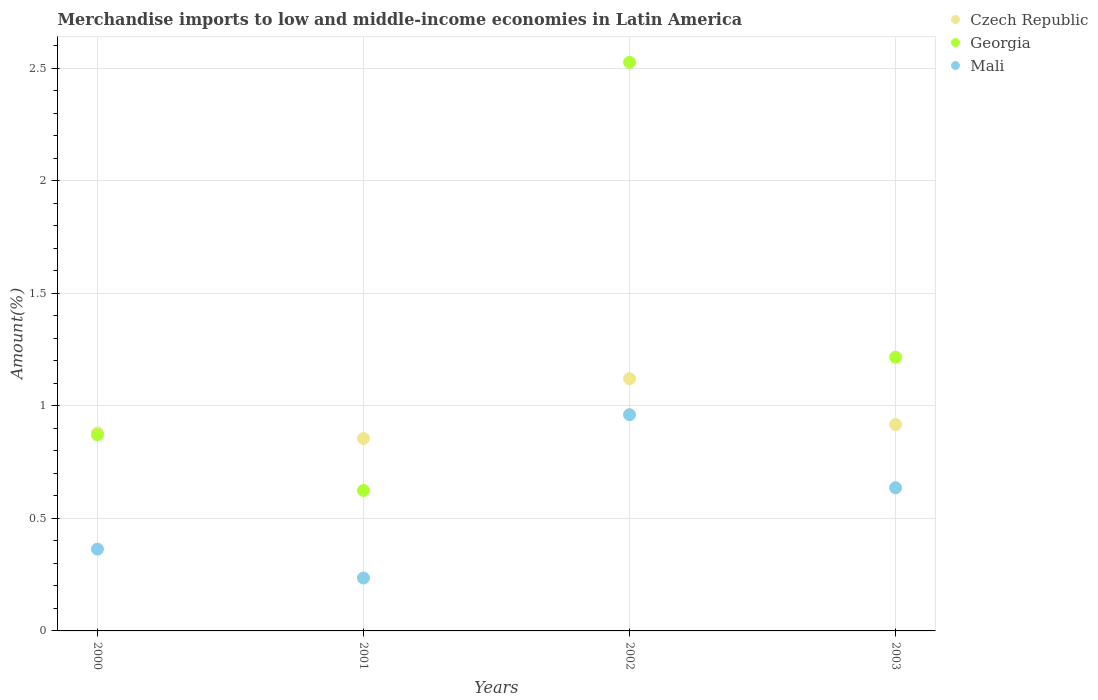How many different coloured dotlines are there?
Ensure brevity in your answer.  3. Is the number of dotlines equal to the number of legend labels?
Offer a very short reply. Yes. What is the percentage of amount earned from merchandise imports in Czech Republic in 2000?
Keep it short and to the point. 0.88. Across all years, what is the maximum percentage of amount earned from merchandise imports in Czech Republic?
Your answer should be very brief. 1.12. Across all years, what is the minimum percentage of amount earned from merchandise imports in Mali?
Your answer should be very brief. 0.24. What is the total percentage of amount earned from merchandise imports in Czech Republic in the graph?
Make the answer very short. 3.77. What is the difference between the percentage of amount earned from merchandise imports in Mali in 2000 and that in 2003?
Your answer should be very brief. -0.27. What is the difference between the percentage of amount earned from merchandise imports in Mali in 2002 and the percentage of amount earned from merchandise imports in Georgia in 2000?
Provide a succinct answer. 0.09. What is the average percentage of amount earned from merchandise imports in Mali per year?
Your response must be concise. 0.55. In the year 2000, what is the difference between the percentage of amount earned from merchandise imports in Georgia and percentage of amount earned from merchandise imports in Czech Republic?
Make the answer very short. -0.01. In how many years, is the percentage of amount earned from merchandise imports in Mali greater than 1.6 %?
Make the answer very short. 0. What is the ratio of the percentage of amount earned from merchandise imports in Georgia in 2001 to that in 2003?
Your answer should be compact. 0.51. Is the difference between the percentage of amount earned from merchandise imports in Georgia in 2000 and 2001 greater than the difference between the percentage of amount earned from merchandise imports in Czech Republic in 2000 and 2001?
Provide a short and direct response. Yes. What is the difference between the highest and the second highest percentage of amount earned from merchandise imports in Mali?
Your response must be concise. 0.32. What is the difference between the highest and the lowest percentage of amount earned from merchandise imports in Georgia?
Provide a succinct answer. 1.9. In how many years, is the percentage of amount earned from merchandise imports in Czech Republic greater than the average percentage of amount earned from merchandise imports in Czech Republic taken over all years?
Your response must be concise. 1. Is the sum of the percentage of amount earned from merchandise imports in Czech Republic in 2001 and 2002 greater than the maximum percentage of amount earned from merchandise imports in Georgia across all years?
Keep it short and to the point. No. Is the percentage of amount earned from merchandise imports in Georgia strictly greater than the percentage of amount earned from merchandise imports in Czech Republic over the years?
Provide a succinct answer. No. Is the percentage of amount earned from merchandise imports in Georgia strictly less than the percentage of amount earned from merchandise imports in Mali over the years?
Offer a terse response. No. How many years are there in the graph?
Your answer should be compact. 4. Are the values on the major ticks of Y-axis written in scientific E-notation?
Ensure brevity in your answer.  No. Where does the legend appear in the graph?
Your response must be concise. Top right. How many legend labels are there?
Your answer should be very brief. 3. What is the title of the graph?
Offer a terse response. Merchandise imports to low and middle-income economies in Latin America. What is the label or title of the X-axis?
Provide a short and direct response. Years. What is the label or title of the Y-axis?
Give a very brief answer. Amount(%). What is the Amount(%) in Czech Republic in 2000?
Ensure brevity in your answer.  0.88. What is the Amount(%) in Georgia in 2000?
Provide a short and direct response. 0.87. What is the Amount(%) in Mali in 2000?
Ensure brevity in your answer.  0.36. What is the Amount(%) of Czech Republic in 2001?
Make the answer very short. 0.86. What is the Amount(%) of Georgia in 2001?
Your answer should be compact. 0.62. What is the Amount(%) of Mali in 2001?
Make the answer very short. 0.24. What is the Amount(%) in Czech Republic in 2002?
Give a very brief answer. 1.12. What is the Amount(%) in Georgia in 2002?
Keep it short and to the point. 2.53. What is the Amount(%) in Mali in 2002?
Keep it short and to the point. 0.96. What is the Amount(%) in Czech Republic in 2003?
Provide a succinct answer. 0.92. What is the Amount(%) of Georgia in 2003?
Offer a terse response. 1.22. What is the Amount(%) in Mali in 2003?
Your response must be concise. 0.64. Across all years, what is the maximum Amount(%) of Czech Republic?
Offer a terse response. 1.12. Across all years, what is the maximum Amount(%) in Georgia?
Ensure brevity in your answer.  2.53. Across all years, what is the maximum Amount(%) of Mali?
Make the answer very short. 0.96. Across all years, what is the minimum Amount(%) of Czech Republic?
Offer a terse response. 0.86. Across all years, what is the minimum Amount(%) in Georgia?
Give a very brief answer. 0.62. Across all years, what is the minimum Amount(%) of Mali?
Your answer should be very brief. 0.24. What is the total Amount(%) of Czech Republic in the graph?
Your answer should be compact. 3.77. What is the total Amount(%) of Georgia in the graph?
Make the answer very short. 5.24. What is the total Amount(%) in Mali in the graph?
Make the answer very short. 2.2. What is the difference between the Amount(%) in Czech Republic in 2000 and that in 2001?
Your answer should be compact. 0.03. What is the difference between the Amount(%) of Georgia in 2000 and that in 2001?
Provide a succinct answer. 0.25. What is the difference between the Amount(%) of Mali in 2000 and that in 2001?
Your answer should be compact. 0.13. What is the difference between the Amount(%) in Czech Republic in 2000 and that in 2002?
Make the answer very short. -0.24. What is the difference between the Amount(%) in Georgia in 2000 and that in 2002?
Your response must be concise. -1.66. What is the difference between the Amount(%) of Mali in 2000 and that in 2002?
Your answer should be compact. -0.6. What is the difference between the Amount(%) in Czech Republic in 2000 and that in 2003?
Ensure brevity in your answer.  -0.04. What is the difference between the Amount(%) of Georgia in 2000 and that in 2003?
Provide a short and direct response. -0.34. What is the difference between the Amount(%) in Mali in 2000 and that in 2003?
Your response must be concise. -0.27. What is the difference between the Amount(%) of Czech Republic in 2001 and that in 2002?
Provide a short and direct response. -0.27. What is the difference between the Amount(%) in Georgia in 2001 and that in 2002?
Your response must be concise. -1.9. What is the difference between the Amount(%) in Mali in 2001 and that in 2002?
Your answer should be very brief. -0.73. What is the difference between the Amount(%) in Czech Republic in 2001 and that in 2003?
Offer a terse response. -0.06. What is the difference between the Amount(%) of Georgia in 2001 and that in 2003?
Keep it short and to the point. -0.59. What is the difference between the Amount(%) of Mali in 2001 and that in 2003?
Offer a terse response. -0.4. What is the difference between the Amount(%) of Czech Republic in 2002 and that in 2003?
Your answer should be compact. 0.2. What is the difference between the Amount(%) in Georgia in 2002 and that in 2003?
Provide a short and direct response. 1.31. What is the difference between the Amount(%) in Mali in 2002 and that in 2003?
Offer a terse response. 0.32. What is the difference between the Amount(%) of Czech Republic in 2000 and the Amount(%) of Georgia in 2001?
Offer a very short reply. 0.26. What is the difference between the Amount(%) in Czech Republic in 2000 and the Amount(%) in Mali in 2001?
Provide a short and direct response. 0.65. What is the difference between the Amount(%) in Georgia in 2000 and the Amount(%) in Mali in 2001?
Your answer should be compact. 0.64. What is the difference between the Amount(%) in Czech Republic in 2000 and the Amount(%) in Georgia in 2002?
Give a very brief answer. -1.65. What is the difference between the Amount(%) in Czech Republic in 2000 and the Amount(%) in Mali in 2002?
Your response must be concise. -0.08. What is the difference between the Amount(%) of Georgia in 2000 and the Amount(%) of Mali in 2002?
Provide a succinct answer. -0.09. What is the difference between the Amount(%) of Czech Republic in 2000 and the Amount(%) of Georgia in 2003?
Give a very brief answer. -0.34. What is the difference between the Amount(%) of Czech Republic in 2000 and the Amount(%) of Mali in 2003?
Your response must be concise. 0.24. What is the difference between the Amount(%) in Georgia in 2000 and the Amount(%) in Mali in 2003?
Provide a succinct answer. 0.24. What is the difference between the Amount(%) in Czech Republic in 2001 and the Amount(%) in Georgia in 2002?
Your answer should be very brief. -1.67. What is the difference between the Amount(%) in Czech Republic in 2001 and the Amount(%) in Mali in 2002?
Ensure brevity in your answer.  -0.11. What is the difference between the Amount(%) of Georgia in 2001 and the Amount(%) of Mali in 2002?
Give a very brief answer. -0.34. What is the difference between the Amount(%) of Czech Republic in 2001 and the Amount(%) of Georgia in 2003?
Ensure brevity in your answer.  -0.36. What is the difference between the Amount(%) in Czech Republic in 2001 and the Amount(%) in Mali in 2003?
Provide a succinct answer. 0.22. What is the difference between the Amount(%) in Georgia in 2001 and the Amount(%) in Mali in 2003?
Make the answer very short. -0.01. What is the difference between the Amount(%) of Czech Republic in 2002 and the Amount(%) of Georgia in 2003?
Your answer should be compact. -0.1. What is the difference between the Amount(%) in Czech Republic in 2002 and the Amount(%) in Mali in 2003?
Your answer should be very brief. 0.48. What is the difference between the Amount(%) of Georgia in 2002 and the Amount(%) of Mali in 2003?
Your response must be concise. 1.89. What is the average Amount(%) in Czech Republic per year?
Your answer should be very brief. 0.94. What is the average Amount(%) of Georgia per year?
Make the answer very short. 1.31. What is the average Amount(%) in Mali per year?
Offer a terse response. 0.55. In the year 2000, what is the difference between the Amount(%) of Czech Republic and Amount(%) of Georgia?
Provide a short and direct response. 0.01. In the year 2000, what is the difference between the Amount(%) in Czech Republic and Amount(%) in Mali?
Offer a very short reply. 0.52. In the year 2000, what is the difference between the Amount(%) in Georgia and Amount(%) in Mali?
Give a very brief answer. 0.51. In the year 2001, what is the difference between the Amount(%) in Czech Republic and Amount(%) in Georgia?
Your response must be concise. 0.23. In the year 2001, what is the difference between the Amount(%) of Czech Republic and Amount(%) of Mali?
Offer a very short reply. 0.62. In the year 2001, what is the difference between the Amount(%) in Georgia and Amount(%) in Mali?
Offer a terse response. 0.39. In the year 2002, what is the difference between the Amount(%) of Czech Republic and Amount(%) of Georgia?
Provide a short and direct response. -1.41. In the year 2002, what is the difference between the Amount(%) in Czech Republic and Amount(%) in Mali?
Your response must be concise. 0.16. In the year 2002, what is the difference between the Amount(%) in Georgia and Amount(%) in Mali?
Ensure brevity in your answer.  1.57. In the year 2003, what is the difference between the Amount(%) of Czech Republic and Amount(%) of Georgia?
Your answer should be very brief. -0.3. In the year 2003, what is the difference between the Amount(%) in Czech Republic and Amount(%) in Mali?
Provide a short and direct response. 0.28. In the year 2003, what is the difference between the Amount(%) of Georgia and Amount(%) of Mali?
Give a very brief answer. 0.58. What is the ratio of the Amount(%) in Czech Republic in 2000 to that in 2001?
Ensure brevity in your answer.  1.03. What is the ratio of the Amount(%) of Georgia in 2000 to that in 2001?
Provide a short and direct response. 1.4. What is the ratio of the Amount(%) of Mali in 2000 to that in 2001?
Offer a very short reply. 1.55. What is the ratio of the Amount(%) in Czech Republic in 2000 to that in 2002?
Your answer should be compact. 0.79. What is the ratio of the Amount(%) of Georgia in 2000 to that in 2002?
Your answer should be very brief. 0.34. What is the ratio of the Amount(%) in Mali in 2000 to that in 2002?
Provide a short and direct response. 0.38. What is the ratio of the Amount(%) of Czech Republic in 2000 to that in 2003?
Provide a short and direct response. 0.96. What is the ratio of the Amount(%) of Georgia in 2000 to that in 2003?
Your answer should be compact. 0.72. What is the ratio of the Amount(%) of Mali in 2000 to that in 2003?
Offer a terse response. 0.57. What is the ratio of the Amount(%) of Czech Republic in 2001 to that in 2002?
Your answer should be very brief. 0.76. What is the ratio of the Amount(%) of Georgia in 2001 to that in 2002?
Your answer should be compact. 0.25. What is the ratio of the Amount(%) in Mali in 2001 to that in 2002?
Give a very brief answer. 0.24. What is the ratio of the Amount(%) in Czech Republic in 2001 to that in 2003?
Ensure brevity in your answer.  0.93. What is the ratio of the Amount(%) in Georgia in 2001 to that in 2003?
Provide a succinct answer. 0.51. What is the ratio of the Amount(%) of Mali in 2001 to that in 2003?
Provide a short and direct response. 0.37. What is the ratio of the Amount(%) of Czech Republic in 2002 to that in 2003?
Ensure brevity in your answer.  1.22. What is the ratio of the Amount(%) in Georgia in 2002 to that in 2003?
Keep it short and to the point. 2.08. What is the ratio of the Amount(%) in Mali in 2002 to that in 2003?
Give a very brief answer. 1.51. What is the difference between the highest and the second highest Amount(%) in Czech Republic?
Provide a succinct answer. 0.2. What is the difference between the highest and the second highest Amount(%) of Georgia?
Provide a short and direct response. 1.31. What is the difference between the highest and the second highest Amount(%) of Mali?
Your response must be concise. 0.32. What is the difference between the highest and the lowest Amount(%) in Czech Republic?
Offer a very short reply. 0.27. What is the difference between the highest and the lowest Amount(%) in Georgia?
Provide a succinct answer. 1.9. What is the difference between the highest and the lowest Amount(%) of Mali?
Keep it short and to the point. 0.73. 